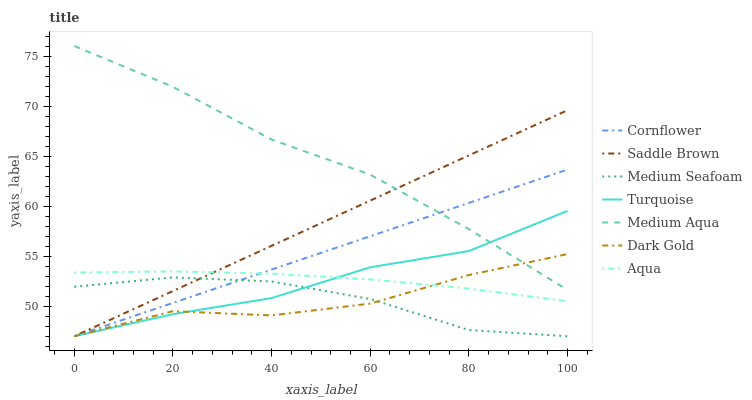Does Dark Gold have the minimum area under the curve?
Answer yes or no. Yes. Does Medium Aqua have the maximum area under the curve?
Answer yes or no. Yes. Does Turquoise have the minimum area under the curve?
Answer yes or no. No. Does Turquoise have the maximum area under the curve?
Answer yes or no. No. Is Cornflower the smoothest?
Answer yes or no. Yes. Is Dark Gold the roughest?
Answer yes or no. Yes. Is Turquoise the smoothest?
Answer yes or no. No. Is Turquoise the roughest?
Answer yes or no. No. Does Cornflower have the lowest value?
Answer yes or no. Yes. Does Aqua have the lowest value?
Answer yes or no. No. Does Medium Aqua have the highest value?
Answer yes or no. Yes. Does Turquoise have the highest value?
Answer yes or no. No. Is Aqua less than Medium Aqua?
Answer yes or no. Yes. Is Medium Aqua greater than Medium Seafoam?
Answer yes or no. Yes. Does Aqua intersect Saddle Brown?
Answer yes or no. Yes. Is Aqua less than Saddle Brown?
Answer yes or no. No. Is Aqua greater than Saddle Brown?
Answer yes or no. No. Does Aqua intersect Medium Aqua?
Answer yes or no. No. 